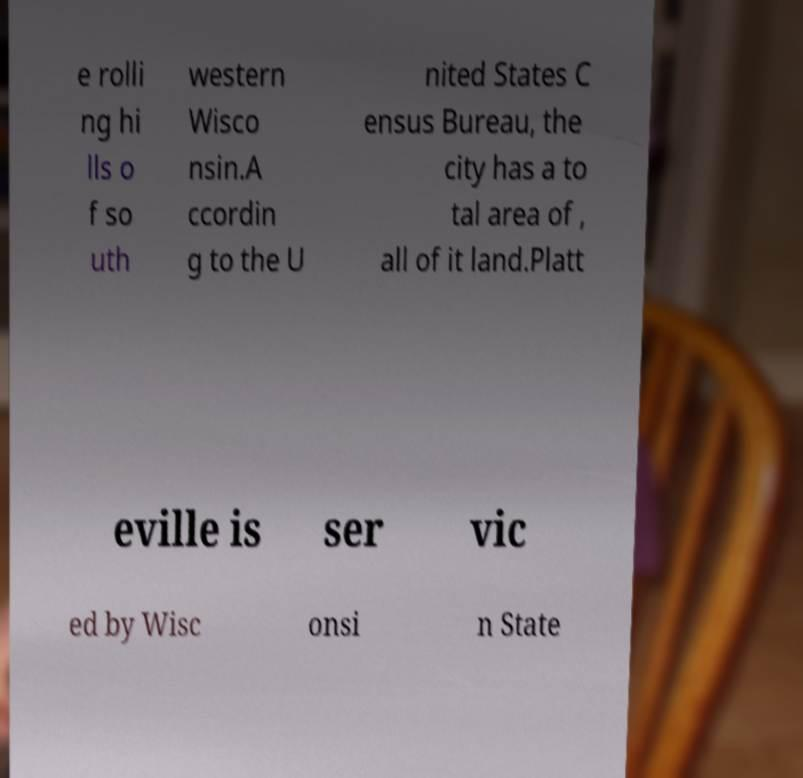Can you read and provide the text displayed in the image?This photo seems to have some interesting text. Can you extract and type it out for me? e rolli ng hi lls o f so uth western Wisco nsin.A ccordin g to the U nited States C ensus Bureau, the city has a to tal area of , all of it land.Platt eville is ser vic ed by Wisc onsi n State 